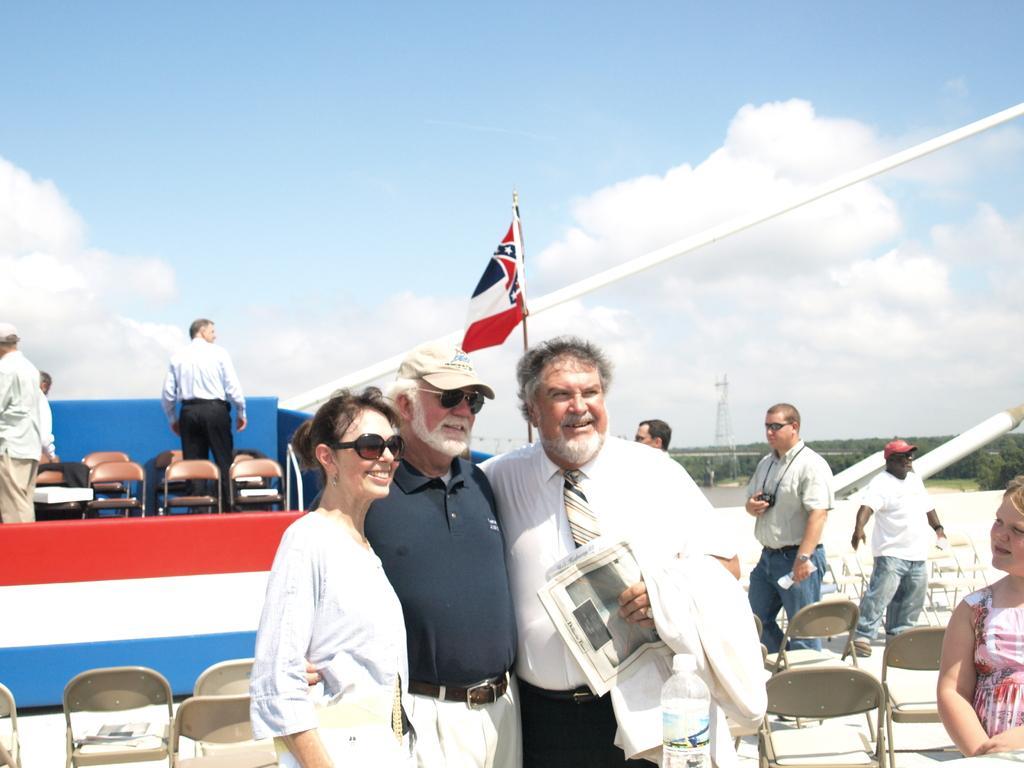In one or two sentences, can you explain what this image depicts? In this image we can see many people. There is a flag in the image. There is a blue and a slightly cloudy sky in the image. There are many chairs in the image. A person is holding an object in his hand in the image. 